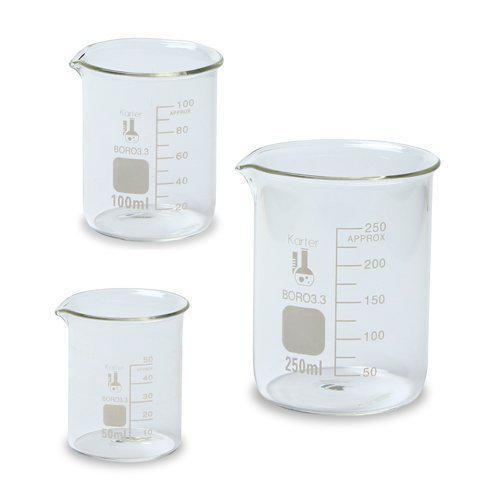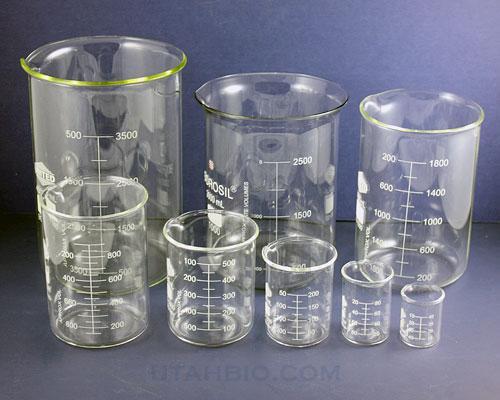The first image is the image on the left, the second image is the image on the right. Considering the images on both sides, is "The right image includes a beaker containing bright red liquid." valid? Answer yes or no. No. 